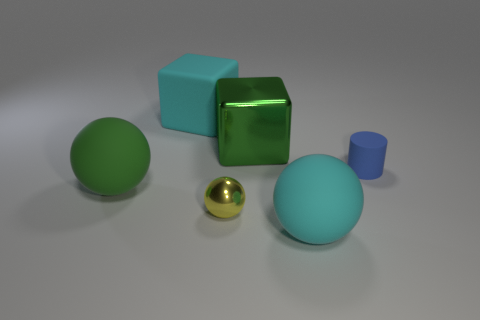Add 2 cubes. How many objects exist? 8 Subtract all cylinders. How many objects are left? 5 Subtract all shiny blocks. Subtract all small blue matte cylinders. How many objects are left? 4 Add 4 small yellow objects. How many small yellow objects are left? 5 Add 1 small red metal things. How many small red metal things exist? 1 Subtract 1 green blocks. How many objects are left? 5 